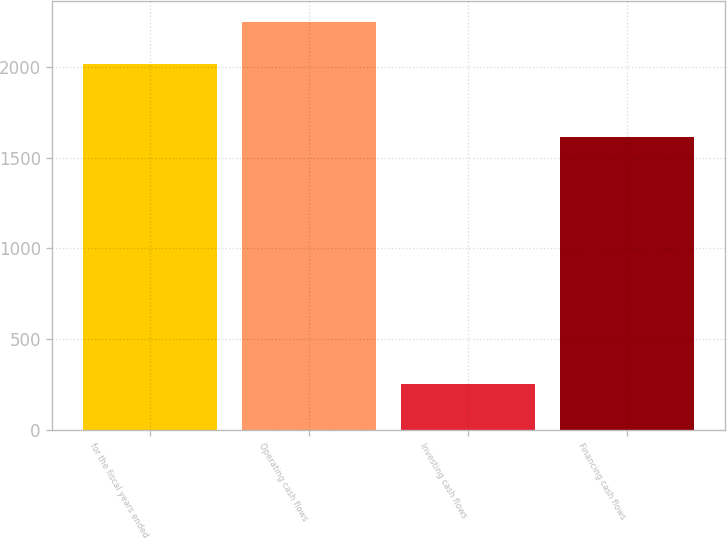Convert chart to OTSL. <chart><loc_0><loc_0><loc_500><loc_500><bar_chart><fcel>for the fiscal years ended<fcel>Operating cash flows<fcel>Investing cash flows<fcel>Financing cash flows<nl><fcel>2015<fcel>2252<fcel>248.9<fcel>1612.2<nl></chart> 